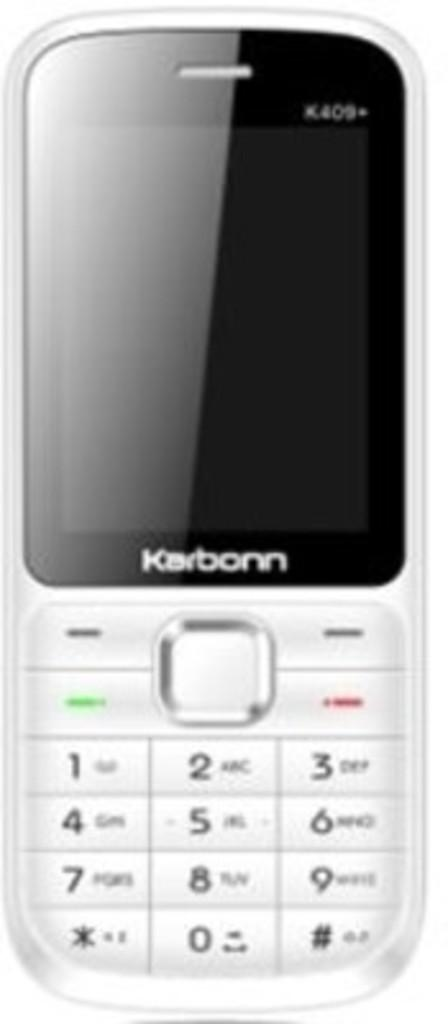Provide a one-sentence caption for the provided image. An older, Karborn cell phone with buttons that have numbers on them, rather than a touch screen is against a plain, white back ground. 